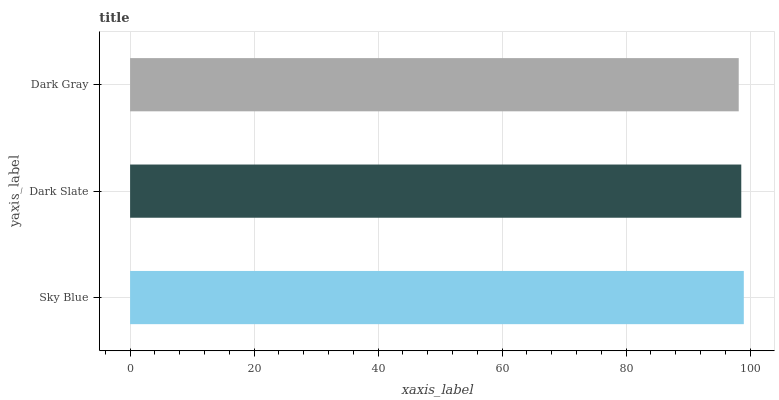Is Dark Gray the minimum?
Answer yes or no. Yes. Is Sky Blue the maximum?
Answer yes or no. Yes. Is Dark Slate the minimum?
Answer yes or no. No. Is Dark Slate the maximum?
Answer yes or no. No. Is Sky Blue greater than Dark Slate?
Answer yes or no. Yes. Is Dark Slate less than Sky Blue?
Answer yes or no. Yes. Is Dark Slate greater than Sky Blue?
Answer yes or no. No. Is Sky Blue less than Dark Slate?
Answer yes or no. No. Is Dark Slate the high median?
Answer yes or no. Yes. Is Dark Slate the low median?
Answer yes or no. Yes. Is Sky Blue the high median?
Answer yes or no. No. Is Sky Blue the low median?
Answer yes or no. No. 